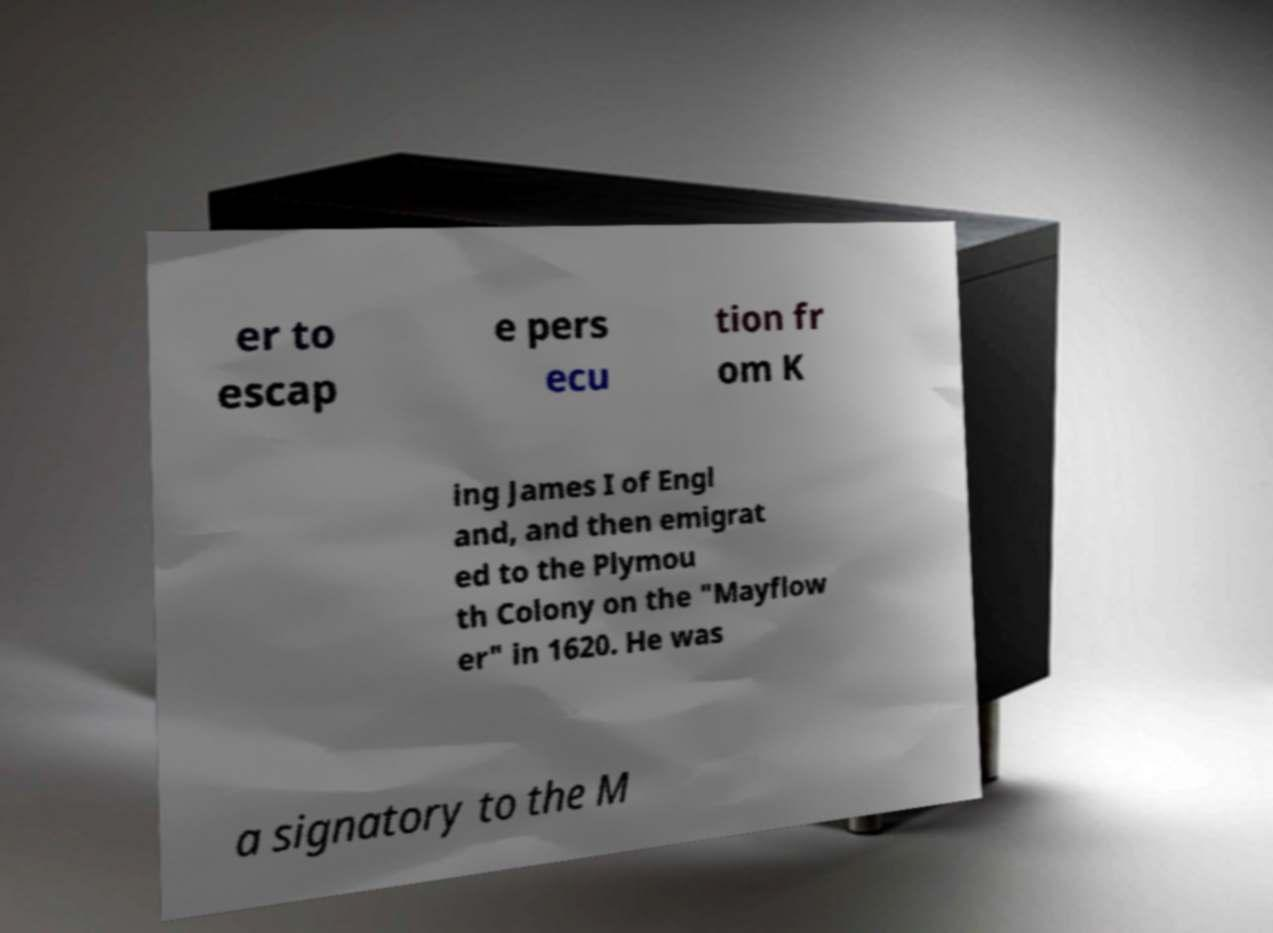Could you extract and type out the text from this image? er to escap e pers ecu tion fr om K ing James I of Engl and, and then emigrat ed to the Plymou th Colony on the "Mayflow er" in 1620. He was a signatory to the M 